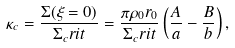<formula> <loc_0><loc_0><loc_500><loc_500>\kappa _ { c } = \frac { \Sigma ( \xi = 0 ) } { \Sigma _ { c } r i t } = \frac { \pi \rho _ { 0 } r _ { 0 } } { \Sigma _ { c } r i t } \left ( \frac { A } { a } - \frac { B } { b } \right ) ,</formula> 